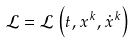Convert formula to latex. <formula><loc_0><loc_0><loc_500><loc_500>\mathcal { L } = \mathcal { L } \left ( t , x ^ { k } , \dot { x } ^ { k } \right )</formula> 